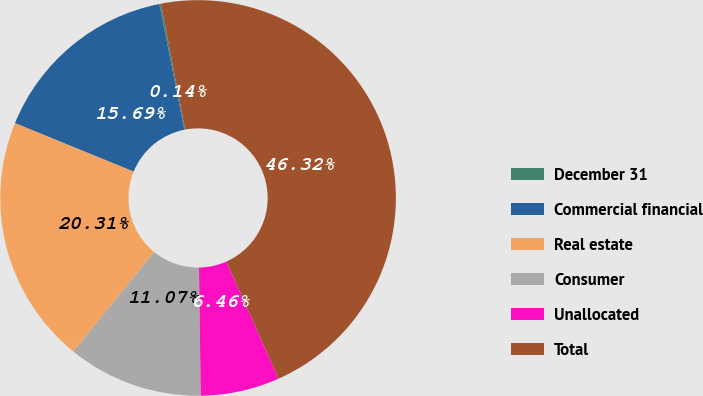<chart> <loc_0><loc_0><loc_500><loc_500><pie_chart><fcel>December 31<fcel>Commercial financial<fcel>Real estate<fcel>Consumer<fcel>Unallocated<fcel>Total<nl><fcel>0.14%<fcel>15.69%<fcel>20.31%<fcel>11.07%<fcel>6.46%<fcel>46.32%<nl></chart> 